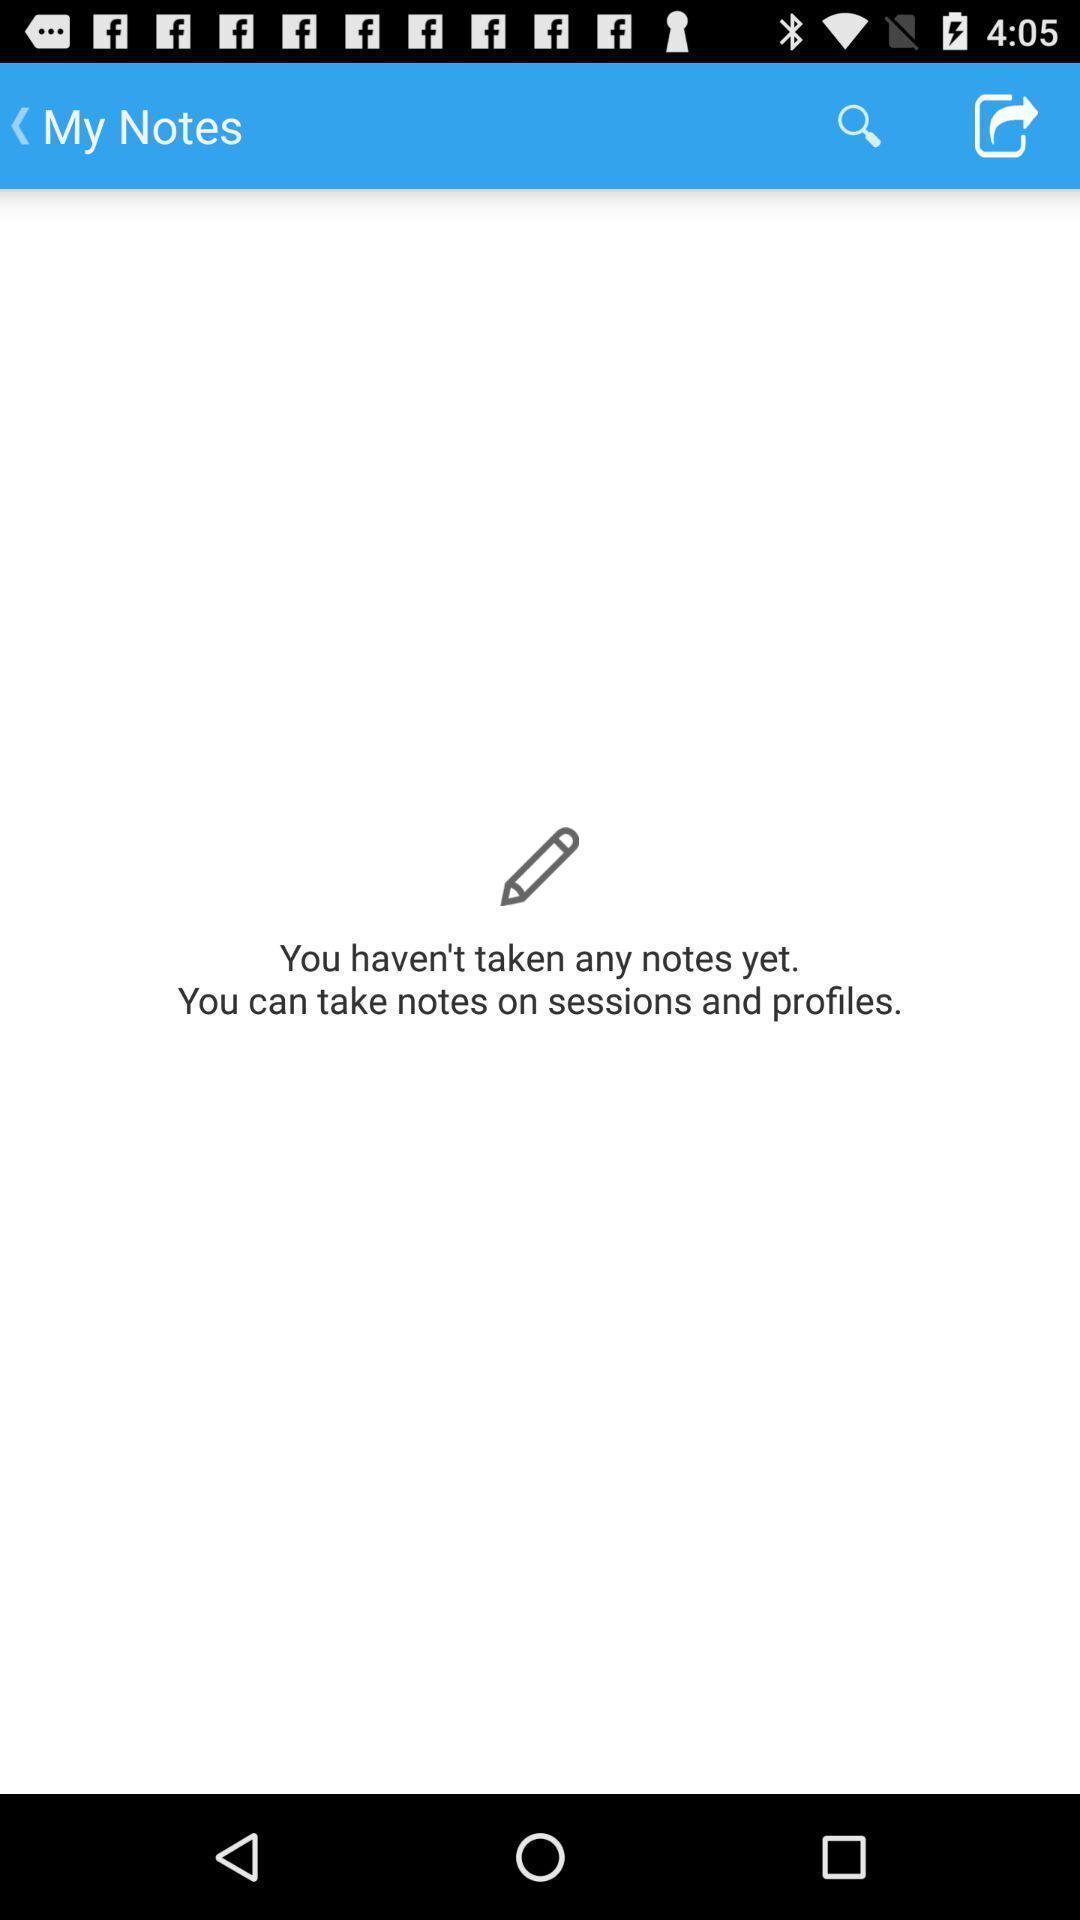What details can you identify in this image? Page showing the interface of a note taking app. 